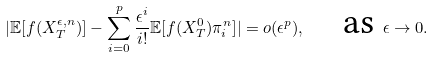Convert formula to latex. <formula><loc_0><loc_0><loc_500><loc_500>| \mathbb { E } [ f ( X _ { T } ^ { \epsilon , n } ) ] - \sum _ { i = 0 } ^ { p } \frac { \epsilon ^ { i } } { i ! } \mathbb { E } [ f ( X _ { T } ^ { 0 } ) \pi ^ { n } _ { i } ] | = o ( \epsilon ^ { p } ) , \quad \text {as } \epsilon \rightarrow 0 .</formula> 